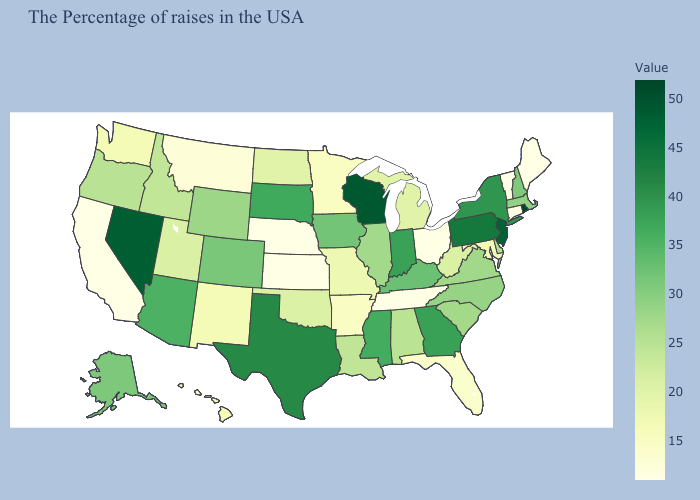Among the states that border Tennessee , does Kentucky have the highest value?
Short answer required. No. Does the map have missing data?
Keep it brief. No. Among the states that border Wisconsin , which have the lowest value?
Be succinct. Minnesota. Does Oregon have a lower value than Florida?
Answer briefly. No. Does the map have missing data?
Give a very brief answer. No. Which states have the highest value in the USA?
Keep it brief. Rhode Island. 